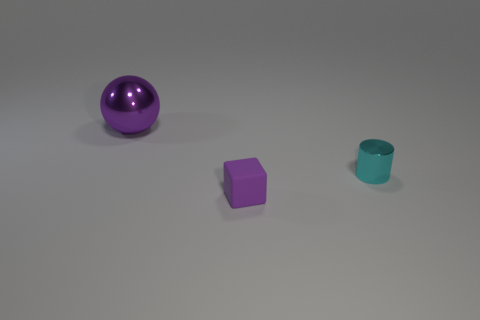Add 1 cyan shiny cylinders. How many objects exist? 4 Subtract all blocks. How many objects are left? 2 Subtract 0 brown cylinders. How many objects are left? 3 Subtract all yellow shiny spheres. Subtract all rubber cubes. How many objects are left? 2 Add 3 cyan things. How many cyan things are left? 4 Add 2 balls. How many balls exist? 3 